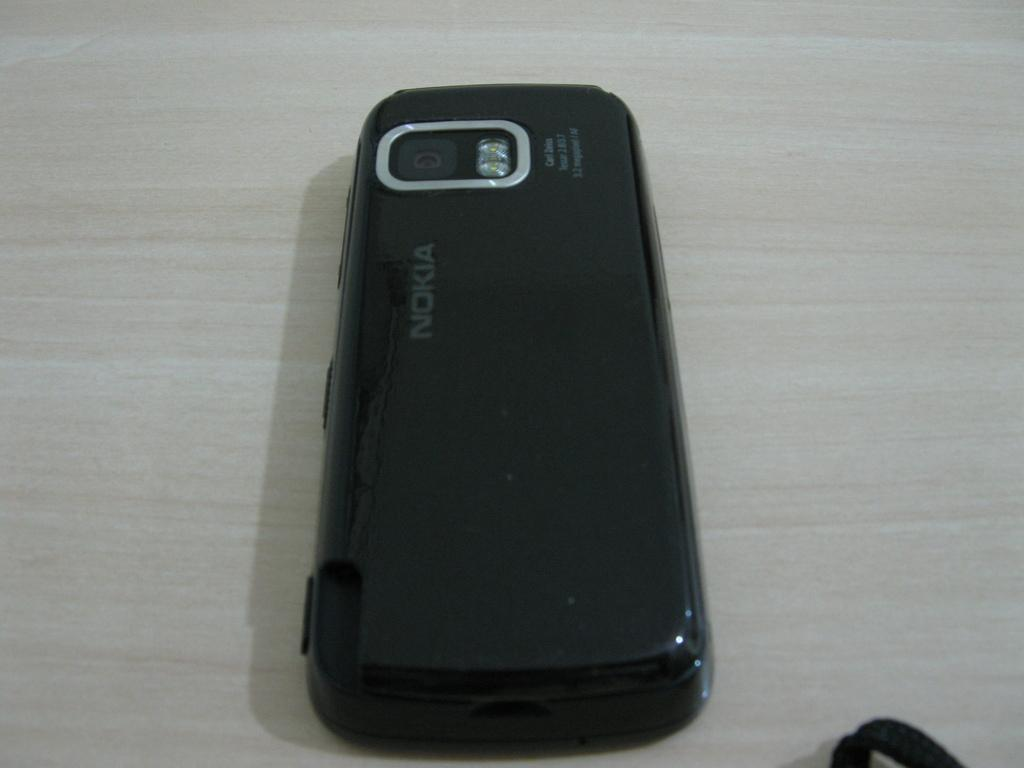Provide a one-sentence caption for the provided image. A nokia cell phone sits face down on a desk. 